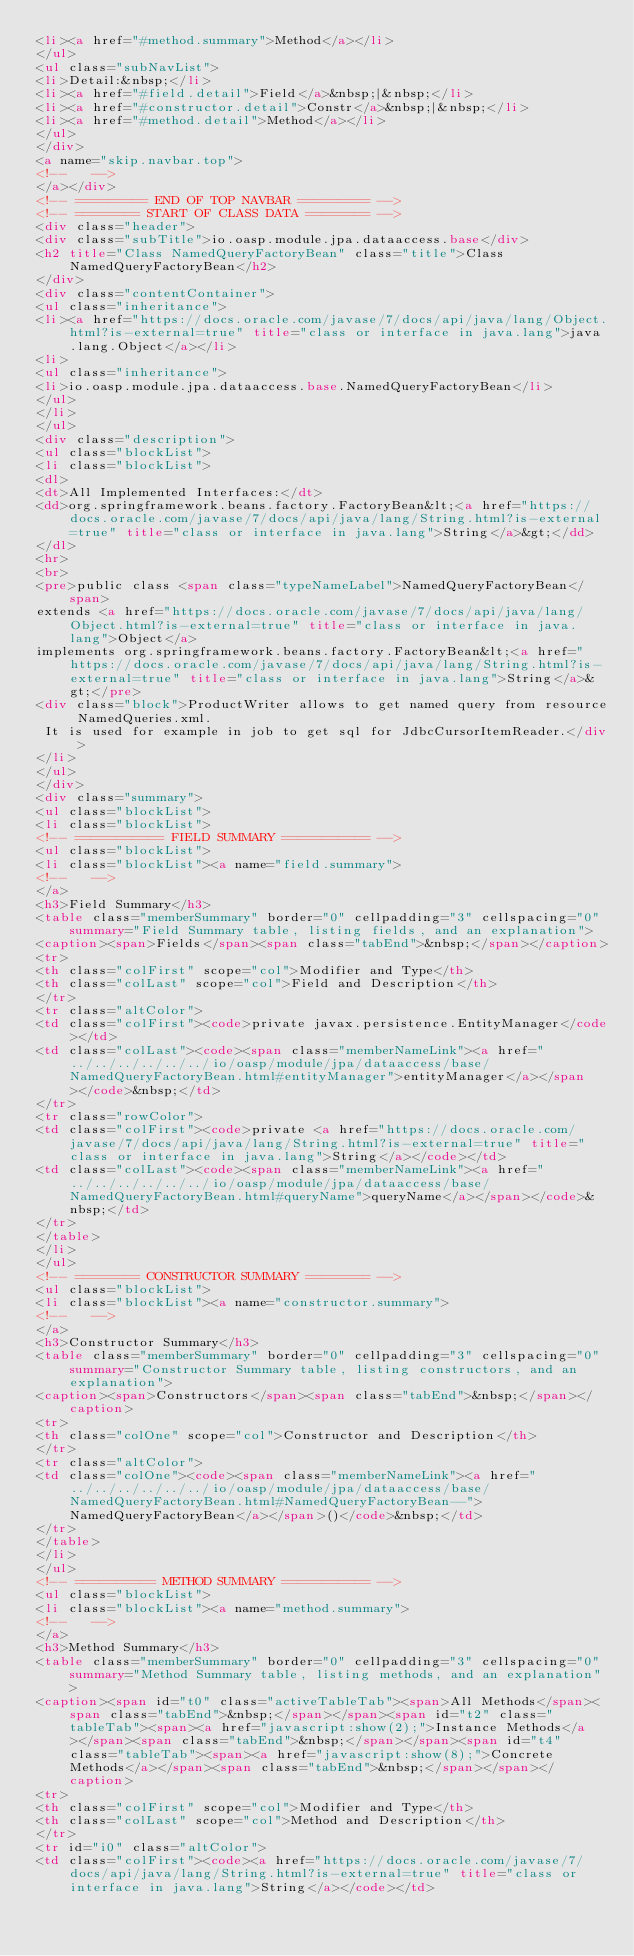<code> <loc_0><loc_0><loc_500><loc_500><_HTML_><li><a href="#method.summary">Method</a></li>
</ul>
<ul class="subNavList">
<li>Detail:&nbsp;</li>
<li><a href="#field.detail">Field</a>&nbsp;|&nbsp;</li>
<li><a href="#constructor.detail">Constr</a>&nbsp;|&nbsp;</li>
<li><a href="#method.detail">Method</a></li>
</ul>
</div>
<a name="skip.navbar.top">
<!--   -->
</a></div>
<!-- ========= END OF TOP NAVBAR ========= -->
<!-- ======== START OF CLASS DATA ======== -->
<div class="header">
<div class="subTitle">io.oasp.module.jpa.dataaccess.base</div>
<h2 title="Class NamedQueryFactoryBean" class="title">Class NamedQueryFactoryBean</h2>
</div>
<div class="contentContainer">
<ul class="inheritance">
<li><a href="https://docs.oracle.com/javase/7/docs/api/java/lang/Object.html?is-external=true" title="class or interface in java.lang">java.lang.Object</a></li>
<li>
<ul class="inheritance">
<li>io.oasp.module.jpa.dataaccess.base.NamedQueryFactoryBean</li>
</ul>
</li>
</ul>
<div class="description">
<ul class="blockList">
<li class="blockList">
<dl>
<dt>All Implemented Interfaces:</dt>
<dd>org.springframework.beans.factory.FactoryBean&lt;<a href="https://docs.oracle.com/javase/7/docs/api/java/lang/String.html?is-external=true" title="class or interface in java.lang">String</a>&gt;</dd>
</dl>
<hr>
<br>
<pre>public class <span class="typeNameLabel">NamedQueryFactoryBean</span>
extends <a href="https://docs.oracle.com/javase/7/docs/api/java/lang/Object.html?is-external=true" title="class or interface in java.lang">Object</a>
implements org.springframework.beans.factory.FactoryBean&lt;<a href="https://docs.oracle.com/javase/7/docs/api/java/lang/String.html?is-external=true" title="class or interface in java.lang">String</a>&gt;</pre>
<div class="block">ProductWriter allows to get named query from resource NamedQueries.xml.
 It is used for example in job to get sql for JdbcCursorItemReader.</div>
</li>
</ul>
</div>
<div class="summary">
<ul class="blockList">
<li class="blockList">
<!-- =========== FIELD SUMMARY =========== -->
<ul class="blockList">
<li class="blockList"><a name="field.summary">
<!--   -->
</a>
<h3>Field Summary</h3>
<table class="memberSummary" border="0" cellpadding="3" cellspacing="0" summary="Field Summary table, listing fields, and an explanation">
<caption><span>Fields</span><span class="tabEnd">&nbsp;</span></caption>
<tr>
<th class="colFirst" scope="col">Modifier and Type</th>
<th class="colLast" scope="col">Field and Description</th>
</tr>
<tr class="altColor">
<td class="colFirst"><code>private javax.persistence.EntityManager</code></td>
<td class="colLast"><code><span class="memberNameLink"><a href="../../../../../../io/oasp/module/jpa/dataaccess/base/NamedQueryFactoryBean.html#entityManager">entityManager</a></span></code>&nbsp;</td>
</tr>
<tr class="rowColor">
<td class="colFirst"><code>private <a href="https://docs.oracle.com/javase/7/docs/api/java/lang/String.html?is-external=true" title="class or interface in java.lang">String</a></code></td>
<td class="colLast"><code><span class="memberNameLink"><a href="../../../../../../io/oasp/module/jpa/dataaccess/base/NamedQueryFactoryBean.html#queryName">queryName</a></span></code>&nbsp;</td>
</tr>
</table>
</li>
</ul>
<!-- ======== CONSTRUCTOR SUMMARY ======== -->
<ul class="blockList">
<li class="blockList"><a name="constructor.summary">
<!--   -->
</a>
<h3>Constructor Summary</h3>
<table class="memberSummary" border="0" cellpadding="3" cellspacing="0" summary="Constructor Summary table, listing constructors, and an explanation">
<caption><span>Constructors</span><span class="tabEnd">&nbsp;</span></caption>
<tr>
<th class="colOne" scope="col">Constructor and Description</th>
</tr>
<tr class="altColor">
<td class="colOne"><code><span class="memberNameLink"><a href="../../../../../../io/oasp/module/jpa/dataaccess/base/NamedQueryFactoryBean.html#NamedQueryFactoryBean--">NamedQueryFactoryBean</a></span>()</code>&nbsp;</td>
</tr>
</table>
</li>
</ul>
<!-- ========== METHOD SUMMARY =========== -->
<ul class="blockList">
<li class="blockList"><a name="method.summary">
<!--   -->
</a>
<h3>Method Summary</h3>
<table class="memberSummary" border="0" cellpadding="3" cellspacing="0" summary="Method Summary table, listing methods, and an explanation">
<caption><span id="t0" class="activeTableTab"><span>All Methods</span><span class="tabEnd">&nbsp;</span></span><span id="t2" class="tableTab"><span><a href="javascript:show(2);">Instance Methods</a></span><span class="tabEnd">&nbsp;</span></span><span id="t4" class="tableTab"><span><a href="javascript:show(8);">Concrete Methods</a></span><span class="tabEnd">&nbsp;</span></span></caption>
<tr>
<th class="colFirst" scope="col">Modifier and Type</th>
<th class="colLast" scope="col">Method and Description</th>
</tr>
<tr id="i0" class="altColor">
<td class="colFirst"><code><a href="https://docs.oracle.com/javase/7/docs/api/java/lang/String.html?is-external=true" title="class or interface in java.lang">String</a></code></td></code> 